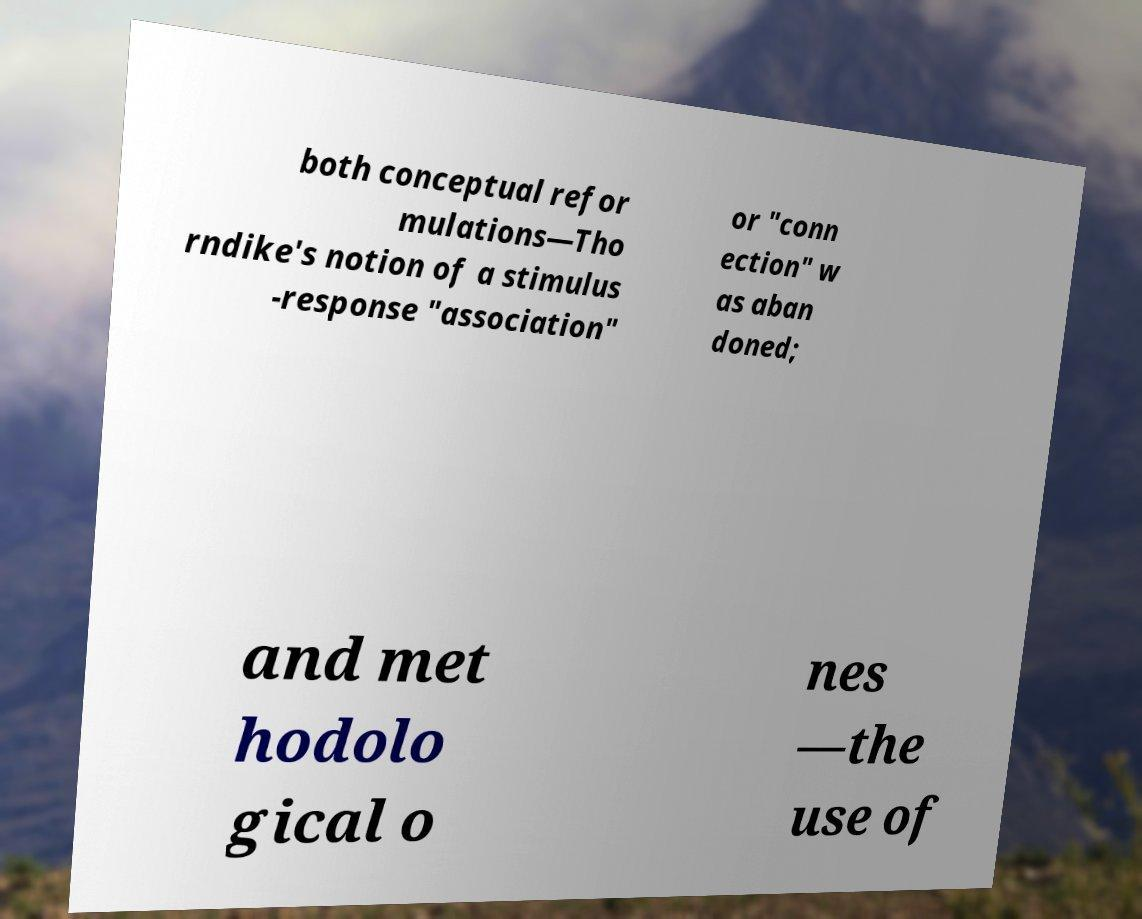For documentation purposes, I need the text within this image transcribed. Could you provide that? both conceptual refor mulations—Tho rndike's notion of a stimulus -response "association" or "conn ection" w as aban doned; and met hodolo gical o nes —the use of 